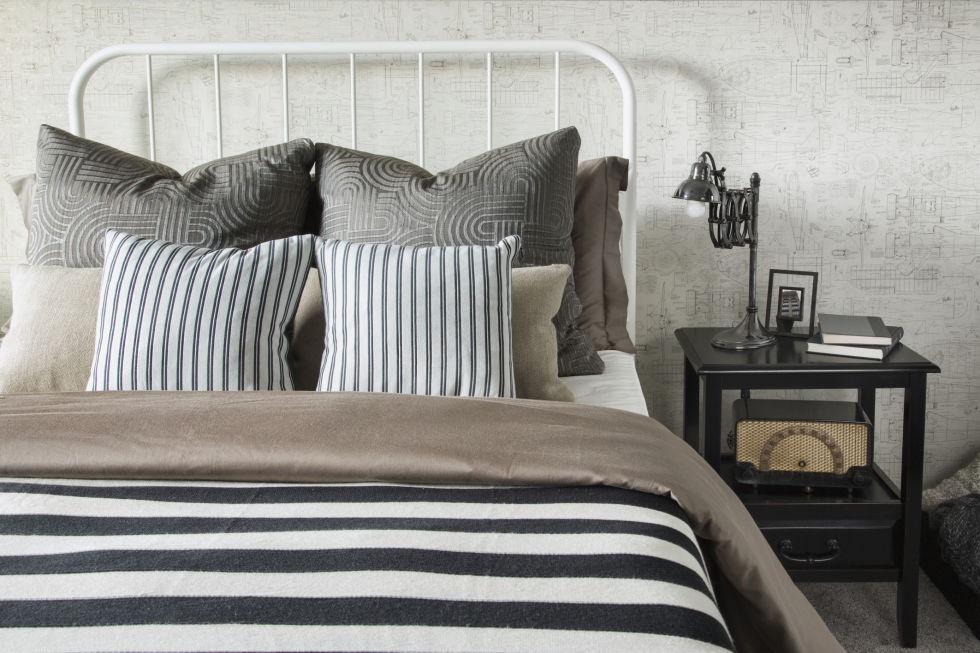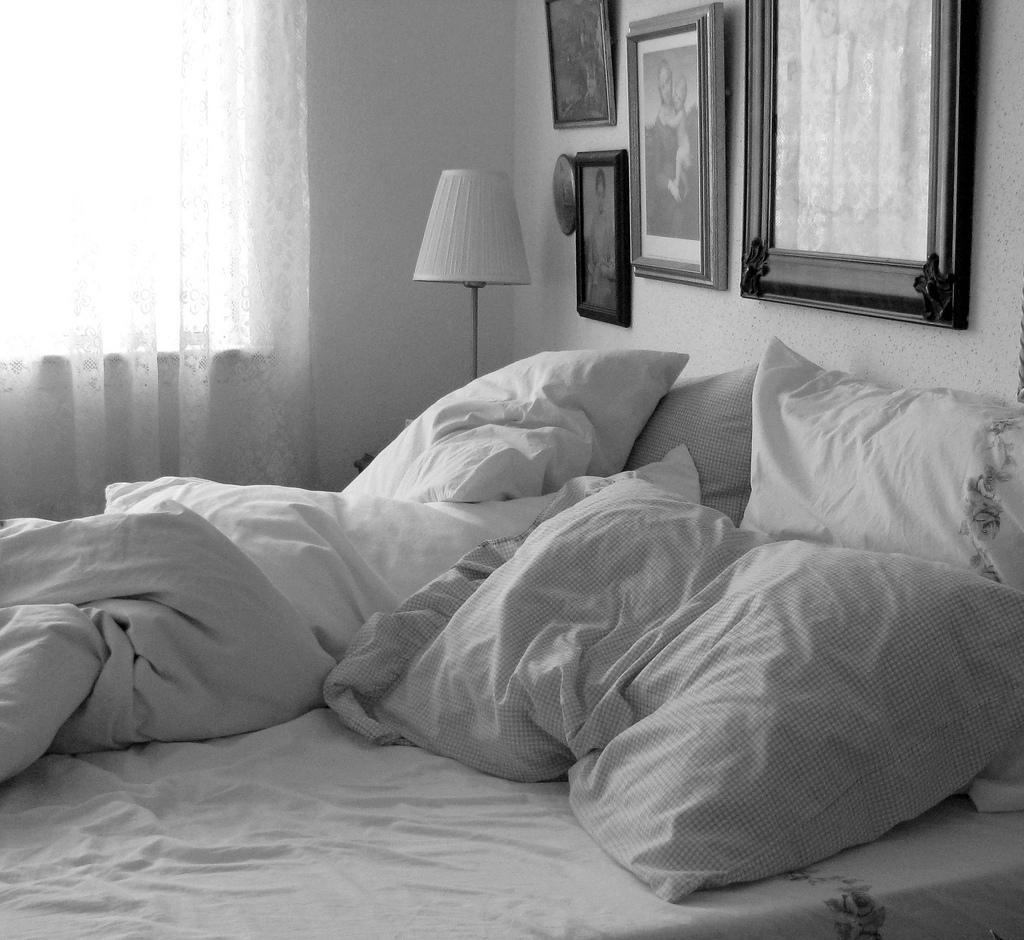The first image is the image on the left, the second image is the image on the right. Evaluate the accuracy of this statement regarding the images: "Rumpled sheets and pillows of an unmade bed are shown in one image.". Is it true? Answer yes or no. Yes. 